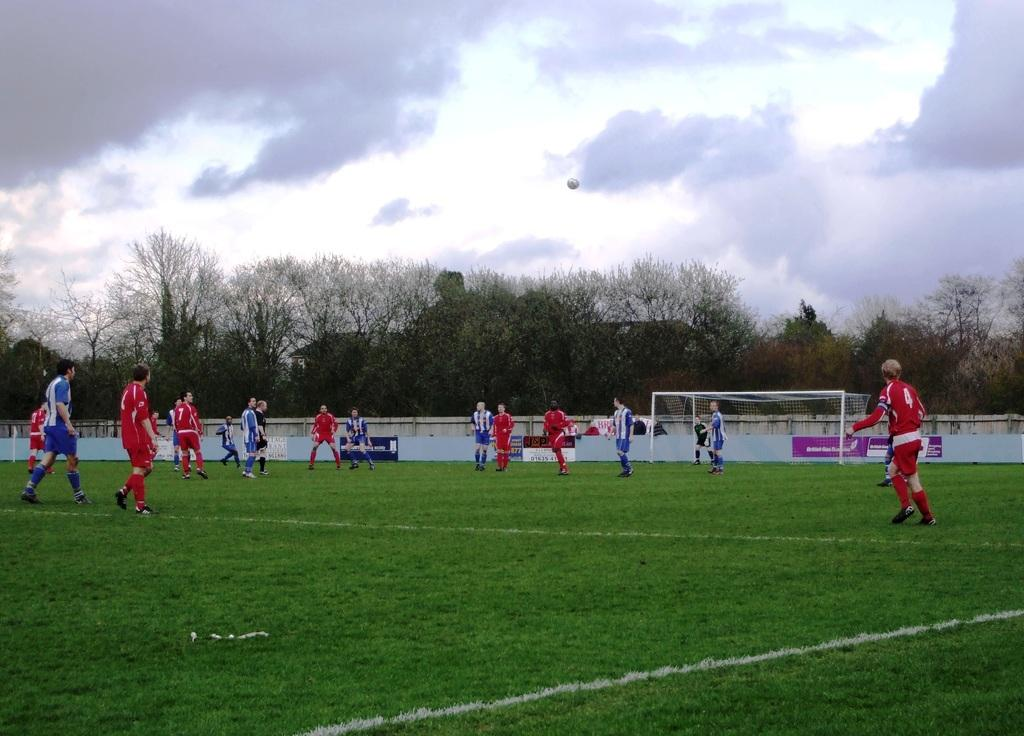What activity are the people in the image engaged in? The people in the image are playing football. What can be seen in the background of the image? There are trees and houses in the background of the image. What is the condition of the sky in the image? The sky is cloudy in the image. How many icicles are hanging from the trees in the image? There are no icicles present in the image, as it is not a winter scene and the sky is cloudy. 